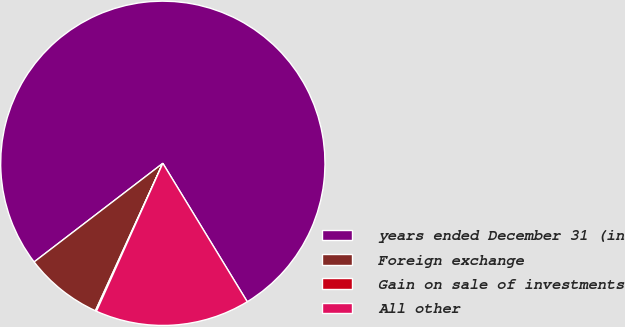Convert chart. <chart><loc_0><loc_0><loc_500><loc_500><pie_chart><fcel>years ended December 31 (in<fcel>Foreign exchange<fcel>Gain on sale of investments<fcel>All other<nl><fcel>76.69%<fcel>7.77%<fcel>0.11%<fcel>15.43%<nl></chart> 